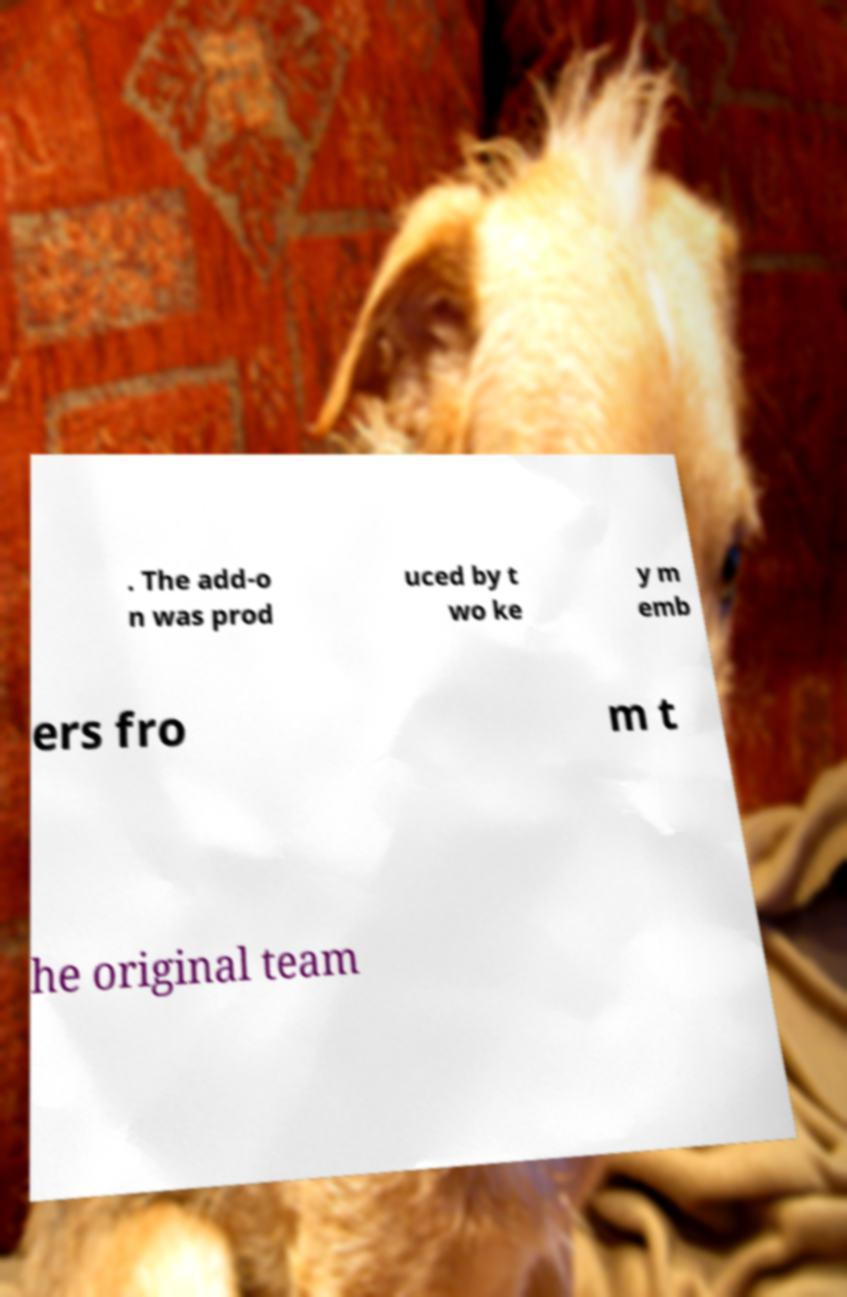Can you accurately transcribe the text from the provided image for me? . The add-o n was prod uced by t wo ke y m emb ers fro m t he original team 